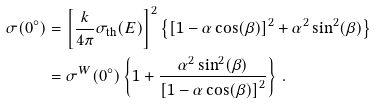<formula> <loc_0><loc_0><loc_500><loc_500>\sigma ( 0 ^ { \circ } ) & = \left [ \frac { k } { 4 \pi } \sigma _ { \text {th} } ( E ) \right ] ^ { 2 } \left \{ \left [ 1 - \alpha \cos ( \beta ) \right ] ^ { 2 } + \alpha ^ { 2 } \sin ^ { 2 } ( \beta ) \right \} \\ & = \sigma ^ { W } ( 0 ^ { \circ } ) \left \{ 1 + \frac { \alpha ^ { 2 } \sin ^ { 2 } ( \beta ) } { \left [ 1 - \alpha \cos ( \beta ) \right ] ^ { 2 } } \right \} \, .</formula> 